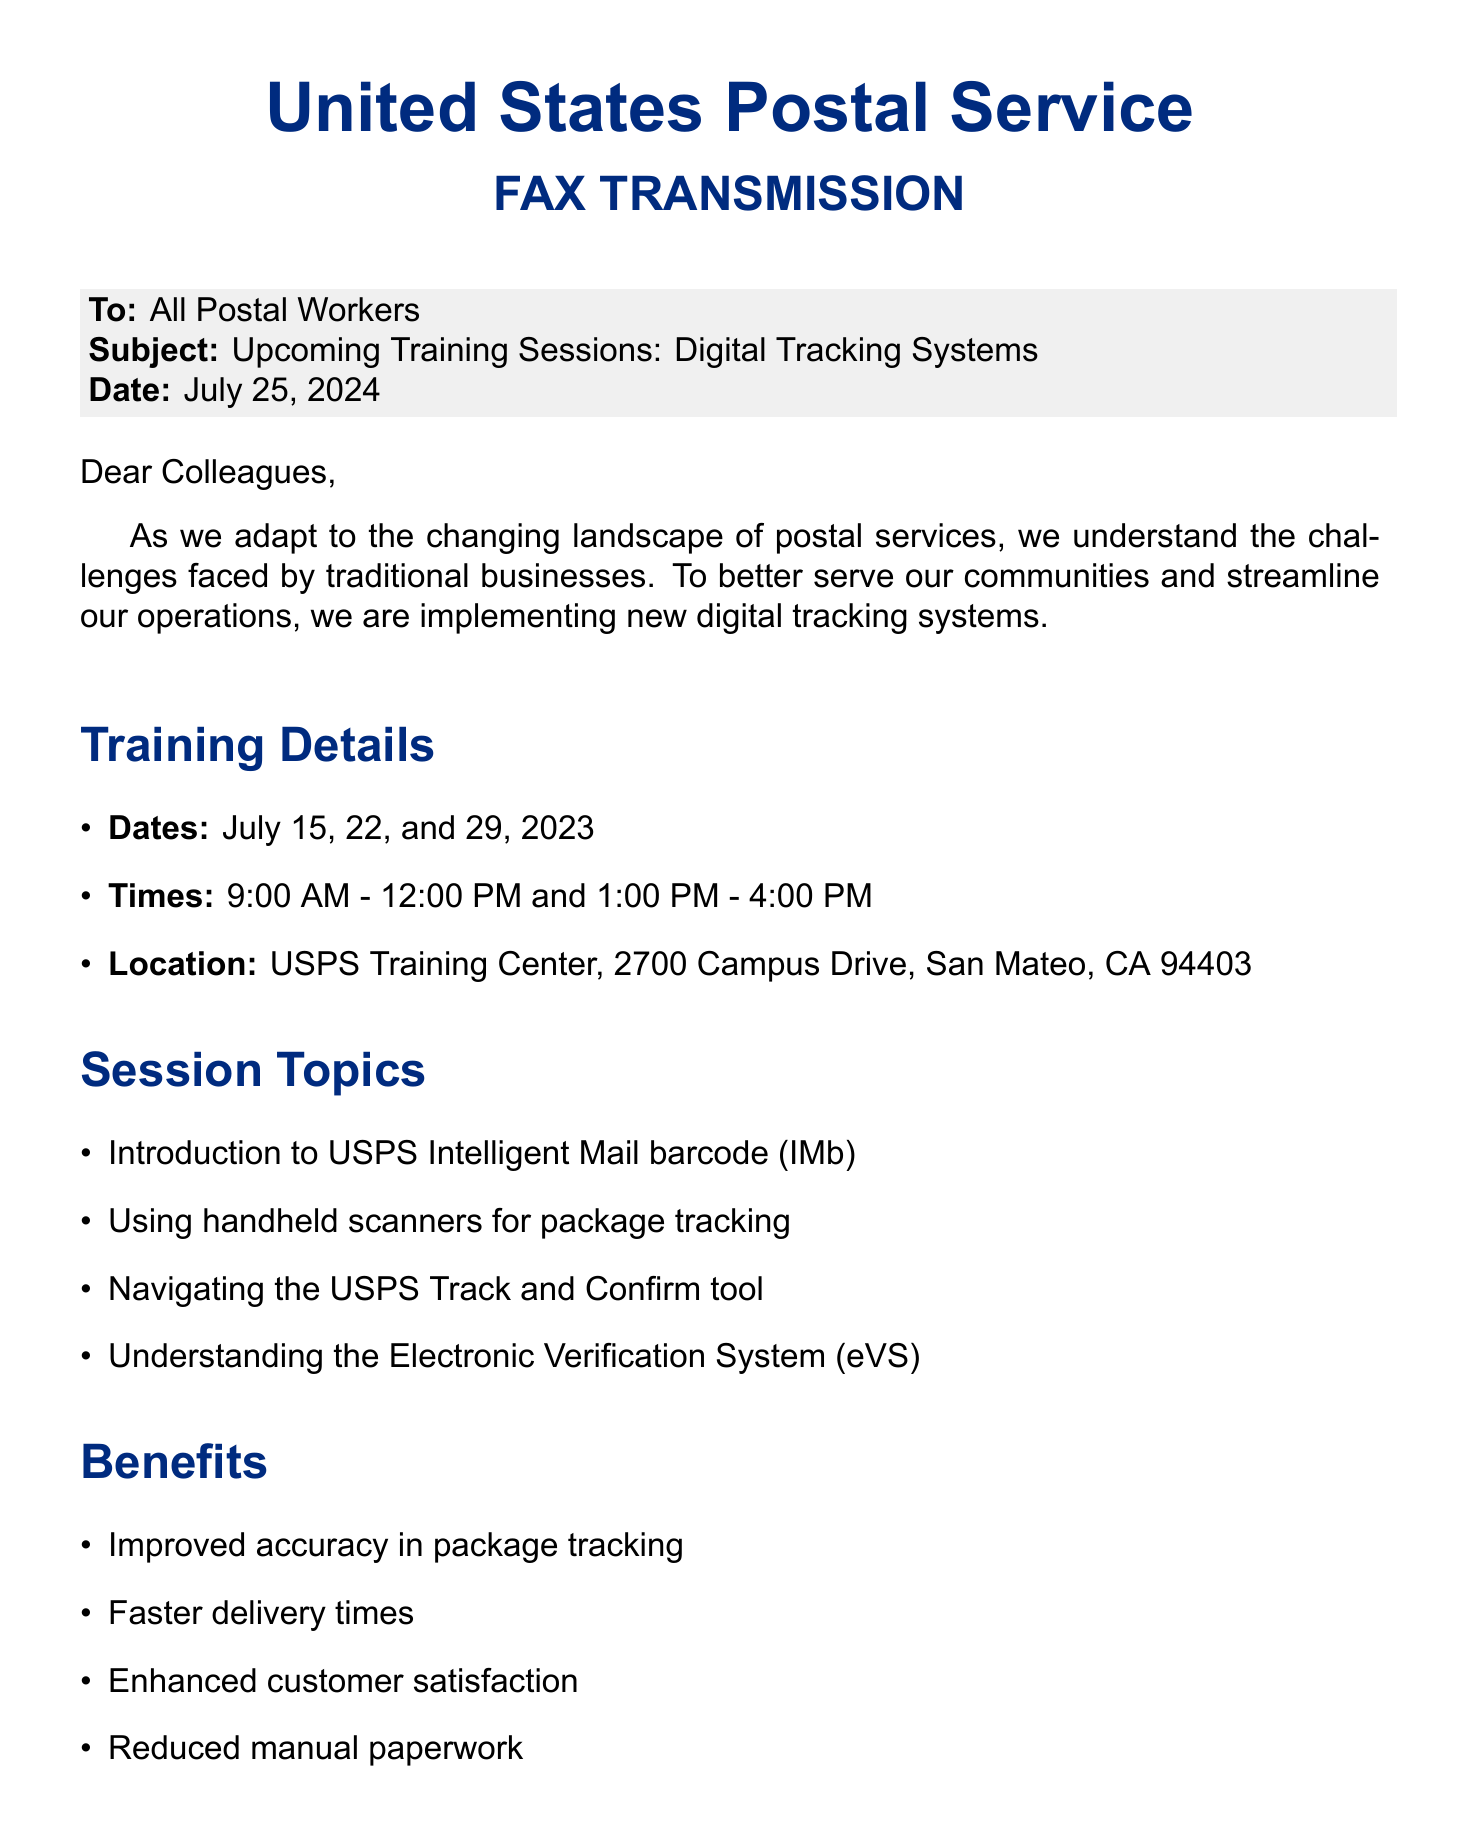What are the training session dates? The document lists the specific dates for the training sessions as July 15, 22, and 29, 2023.
Answer: July 15, 22, and 29, 2023 What is the location of the training sessions? The document specifies that the training will take place at the USPS Training Center, located at 2700 Campus Drive, San Mateo, CA 94403.
Answer: USPS Training Center, 2700 Campus Drive, San Mateo, CA 94403 Who is the contact person for registration? The document mentions John Smith as the contact person for registration inquiries regarding the training sessions.
Answer: John Smith What is the registration deadline? The document states that the deadline for registration is July 10, 2023.
Answer: July 10, 2023 What is one of the session topics covered in the training? The document lists topics including the introduction to USPS Intelligent Mail barcode (IMb) as one of the areas to be covered during the training.
Answer: Introduction to USPS Intelligent Mail barcode (IMb) What benefit is directly related to customer satisfaction? The document indicates that one of the benefits of the training is enhanced customer satisfaction.
Answer: Enhanced customer satisfaction What time do the training sessions start? The document specifies that the training sessions start at 9:00 AM.
Answer: 9:00 AM What tool will trainees learn to navigate? According to the document, one of the tools that trainees will learn to navigate is the USPS Track and Confirm tool.
Answer: USPS Track and Confirm tool 